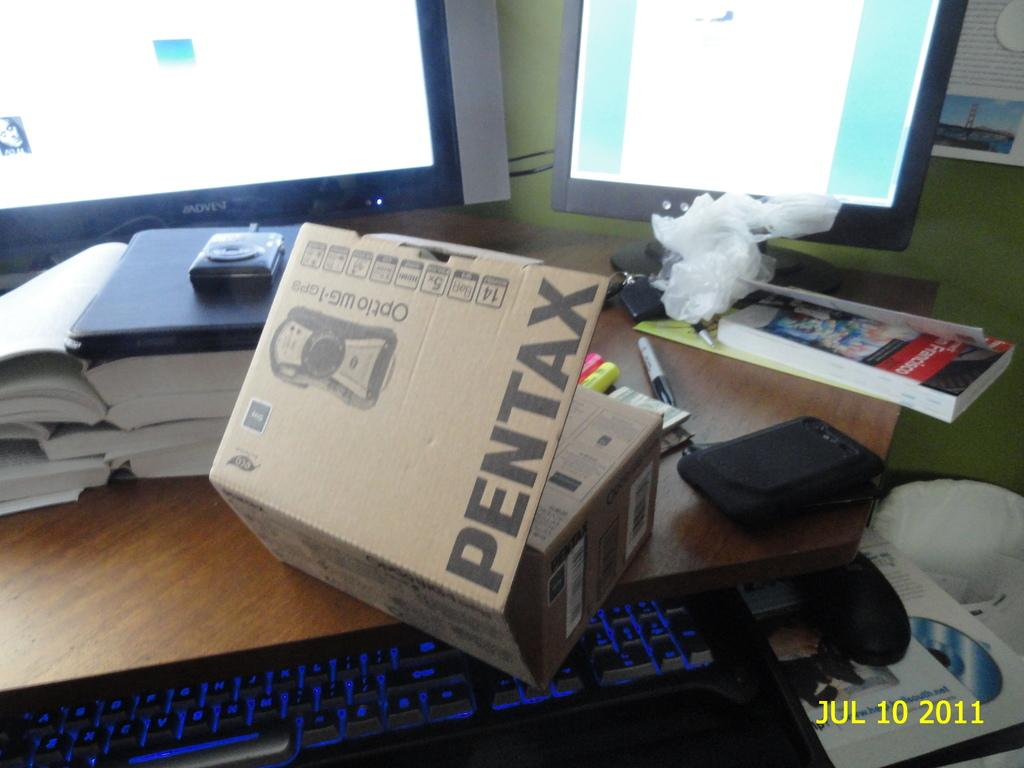What items can be seen on the table in the image? There are books, monitors, and pens on the table in the image. What other objects are present on the table? There are other objects on the table, but their specific details are not mentioned in the provided facts. What type of input device is visible in the image? There is a keyboard and a mouse in the image. What is the purpose of the trash can in the image? The trash can is likely used for disposing of waste in the image. What can be seen on the wall in the image? There is a poster on a wall in the image. How does the airplane join the other objects on the table in the image? There is no airplane present on the table or in the image; it is not a part of the scene. 